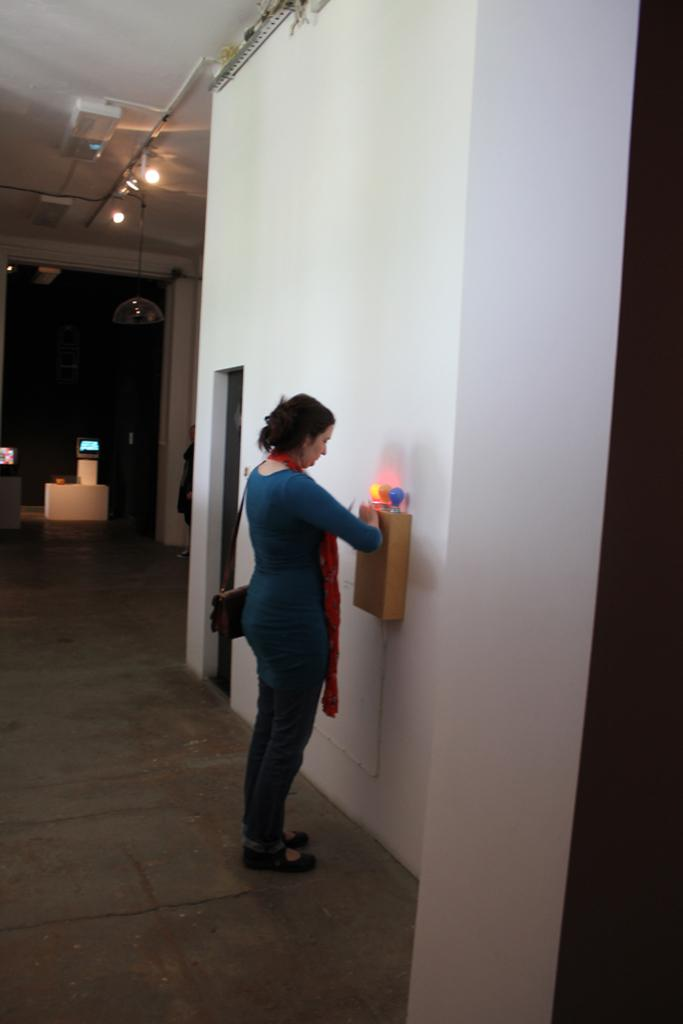What is the main subject of the image? There is a lady standing in the center of the image. What can be seen in the image besides the lady? There are lights, a door, a screen in the background, a person in the background, and a wall visible in the image. Can you describe the background of the image? The background of the image includes a screen and a wall. How many people are visible in the image? There is one lady in the center and one person in the background, making a total of two people visible in the image. What type of glove is the lady wearing in the image? There is no glove visible on the lady in the image. 